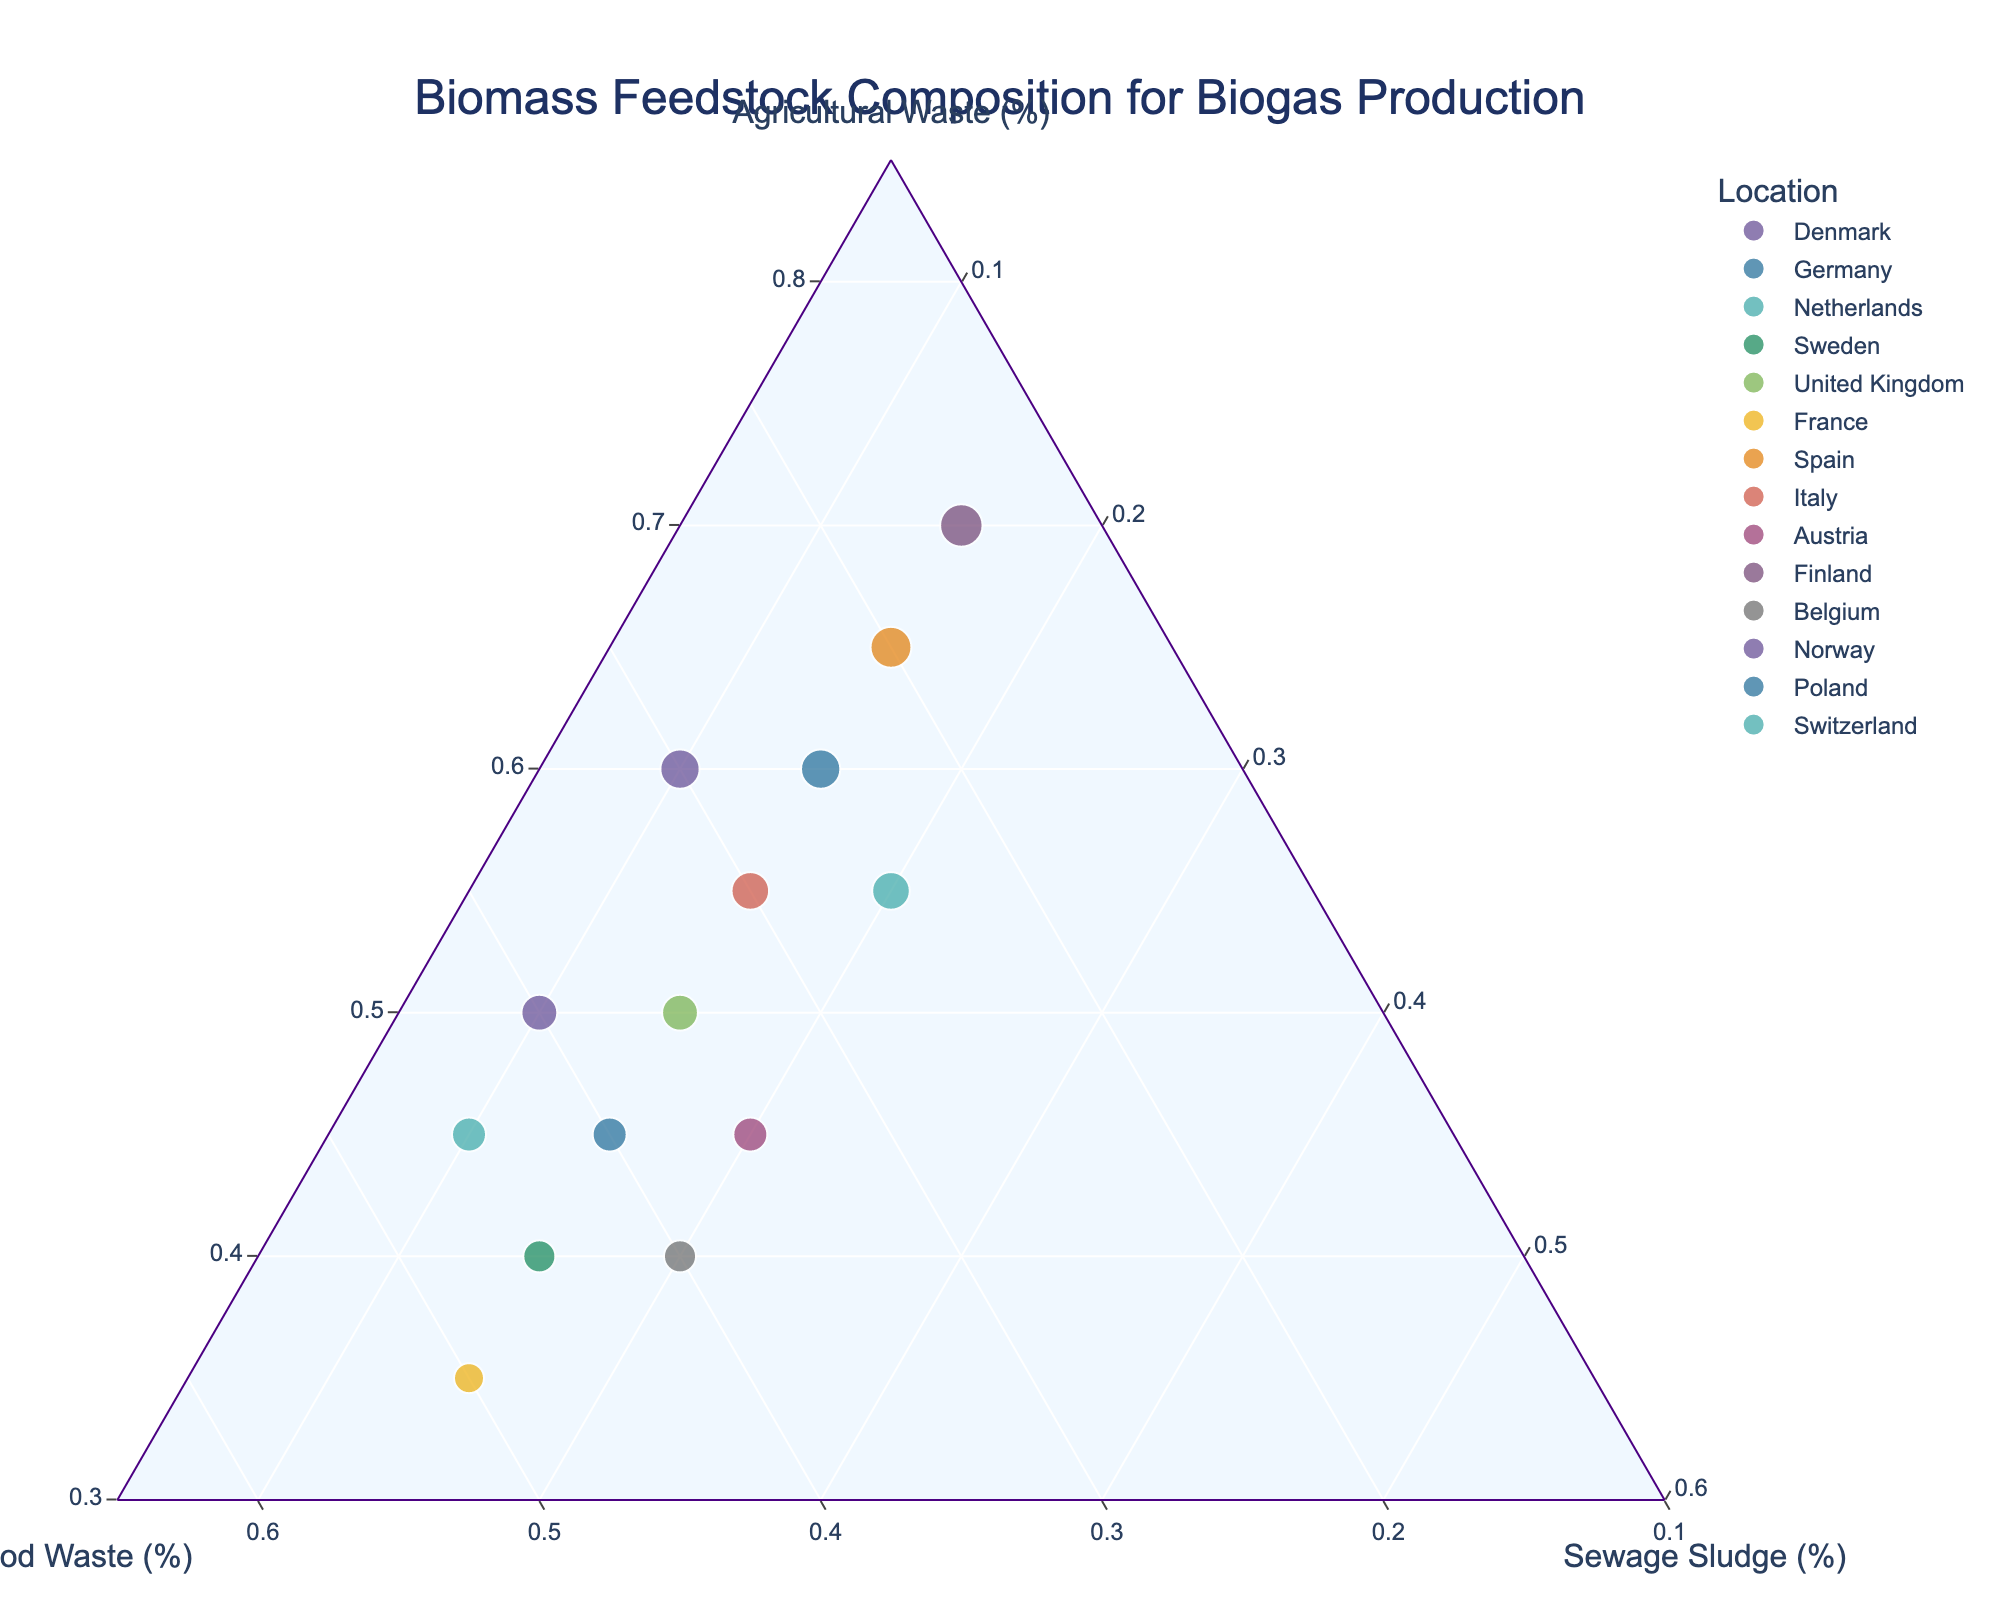What is the title of the plot? The title of the plot is shown at the top and reads "Biomass Feedstock Composition for Biogas Production."
Answer: Biomass Feedstock Composition for Biogas Production Which location has the highest proportion of agricultural waste? By looking at the ternary plot, Finland is at the apex of the agricultural waste axis, indicating that it has the highest proportion of agricultural waste at 70%.
Answer: Finland How many locations have an agricultural waste percentage higher than 50%? By examining the placement of the data points along the agricultural waste axis, we observe Denmark, Netherlands, Spain, Poland, Italy, and Finland having more than 50% agricultural waste. There are 6 such locations.
Answer: 6 What is the range of food waste percentages observed among all locations? By scanning the food waste axis, we find the minimum value at 15% (Finland) and the maximum at 50% (France), resulting in a range of 35% (50% - 15%).
Answer: 35% Which country has the highest combined percentage of food waste and sewage sludge? Adding the proportions of food waste and sewage sludge for each location: 
- Denmark: 30% + 10% = 40%
- Germany: 40% + 15% = 55%
- Netherlands: 25% + 20% = 45%
- Sweden: 45% + 15% = 60%
- United Kingdom: 35% + 15% = 50%
- France: 50% + 15% = 65%
- Spain: 20% + 15% = 35%
- Italy: 30% + 15% = 45%
- Austria: 35% + 20% = 55%
- Finland: 15% + 15% = 30%
- Belgium: 40% + 20% = 60%
- Norway: 40% + 10% = 50%
- Poland: 25% + 15% = 40%
- Switzerland: 45% + 10% = 55%. France has the highest combined percentage of 65%.
Answer: France Is there any location with equal proportions of food waste and agricultural waste? By examining the placement of the data points, only Switzerland has equal proportions for food waste and agricultural waste, with both at 45%.
Answer: Switzerland Which data point is closest to having a 50:50 ratio between food waste and agricultural waste, excluding sewage sludge? Checking the data points, France has a composition where food waste and agricultural waste are 50% and 35% respectively, which is the closest to a 50:50 ratio, excluding sewage sludge.
Answer: France How many countries have exactly 15% sewage sludge in their composition? By identifying the placement of data points along the sewage sludge axis, we see Germany, Sweden, United Kingdom, France, Spain, Italy, and Finland, resulting in 7 countries having exactly 15% sewage sludge.
Answer: 7 Which country has the proportions of 60% agricultural waste, 25% food waste, and 15% sewage sludge? Cross-referencing the given proportions directly with the data points, we find that Poland matches these values.
Answer: Poland 